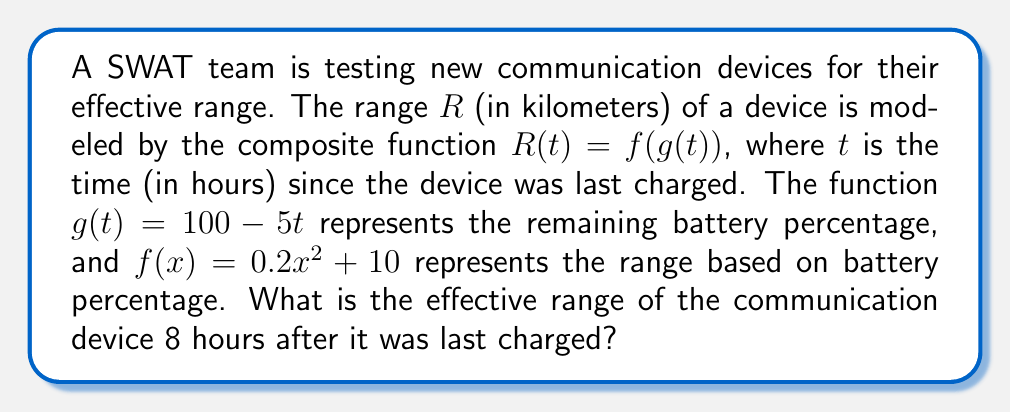Can you answer this question? To solve this problem, we need to use the given composite function $R(t) = f(g(t))$ and follow these steps:

1) First, we need to find $g(8)$, which represents the remaining battery percentage after 8 hours:

   $g(t) = 100 - 5t$
   $g(8) = 100 - 5(8) = 100 - 40 = 60$

2) Now that we know the battery percentage after 8 hours is 60%, we can use this value in the function $f(x)$:

   $f(x) = 0.2x^2 + 10$
   $f(60) = 0.2(60)^2 + 10$

3) Let's calculate this:

   $f(60) = 0.2(3600) + 10$
   $f(60) = 720 + 10 = 730$

4) Therefore, $R(8) = f(g(8)) = f(60) = 730$

The effective range of the communication device 8 hours after it was last charged is 730 kilometers.
Answer: 730 kilometers 